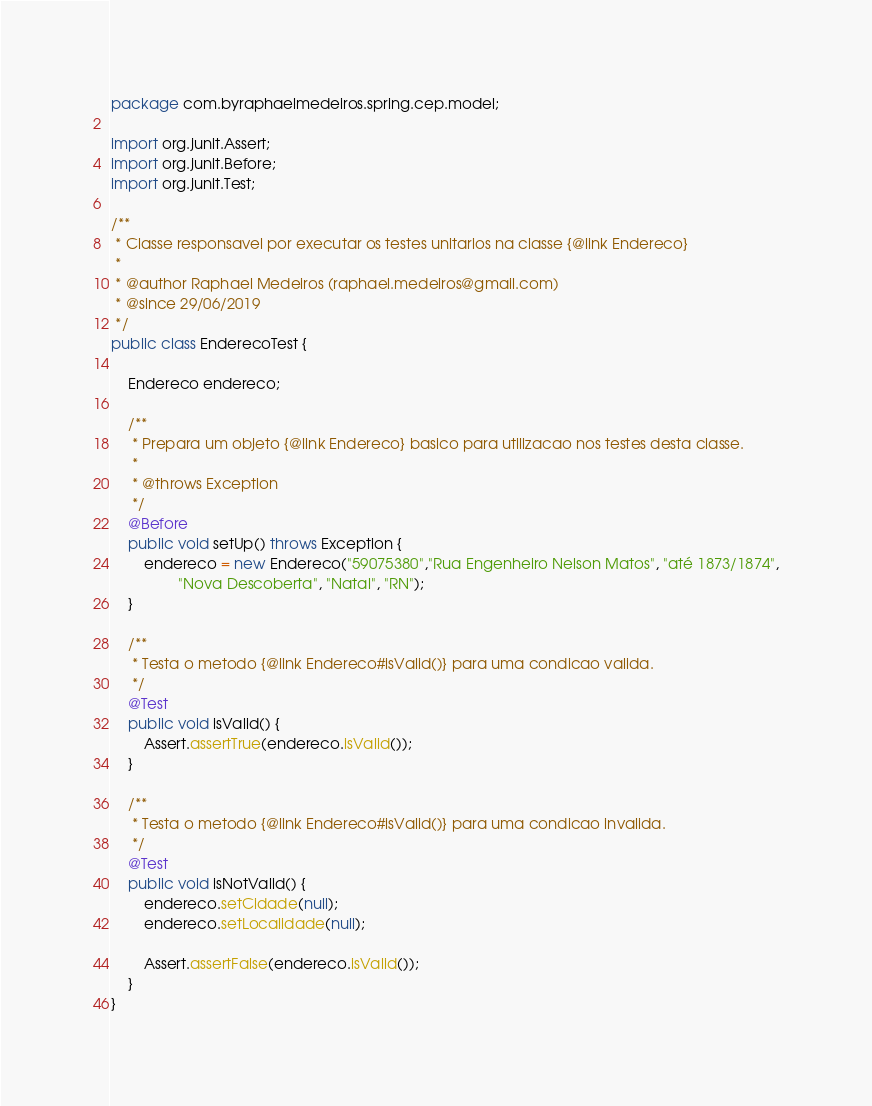<code> <loc_0><loc_0><loc_500><loc_500><_Java_>package com.byraphaelmedeiros.spring.cep.model;

import org.junit.Assert;
import org.junit.Before;
import org.junit.Test;

/**
 * Classe responsavel por executar os testes unitarios na classe {@link Endereco}
 *
 * @author Raphael Medeiros (raphael.medeiros@gmail.com)
 * @since 29/06/2019
 */
public class EnderecoTest {

    Endereco endereco;

    /**
     * Prepara um objeto {@link Endereco} basico para utilizacao nos testes desta classe.
     *
     * @throws Exception
     */
    @Before
    public void setUp() throws Exception {
        endereco = new Endereco("59075380","Rua Engenheiro Nelson Matos", "até 1873/1874",
                "Nova Descoberta", "Natal", "RN");
    }

    /**
     * Testa o metodo {@link Endereco#isValid()} para uma condicao valida.
     */
    @Test
    public void isValid() {
        Assert.assertTrue(endereco.isValid());
    }

    /**
     * Testa o metodo {@link Endereco#isValid()} para uma condicao invalida.
     */
    @Test
    public void isNotValid() {
        endereco.setCidade(null);
        endereco.setLocalidade(null);

        Assert.assertFalse(endereco.isValid());
    }
}</code> 